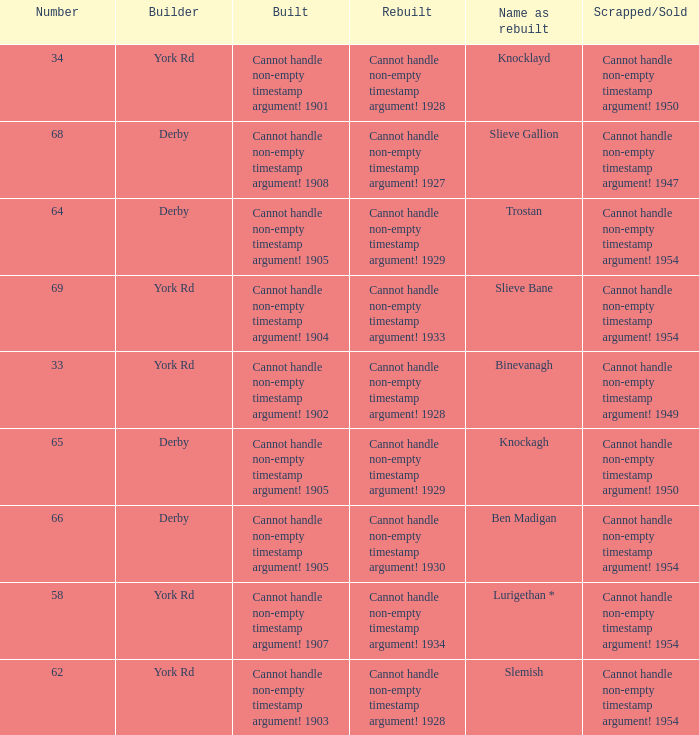Which Rebuilt has a Builder of derby, and a Name as rebuilt of ben madigan? Cannot handle non-empty timestamp argument! 1930. 